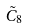<formula> <loc_0><loc_0><loc_500><loc_500>\tilde { C } _ { 8 }</formula> 